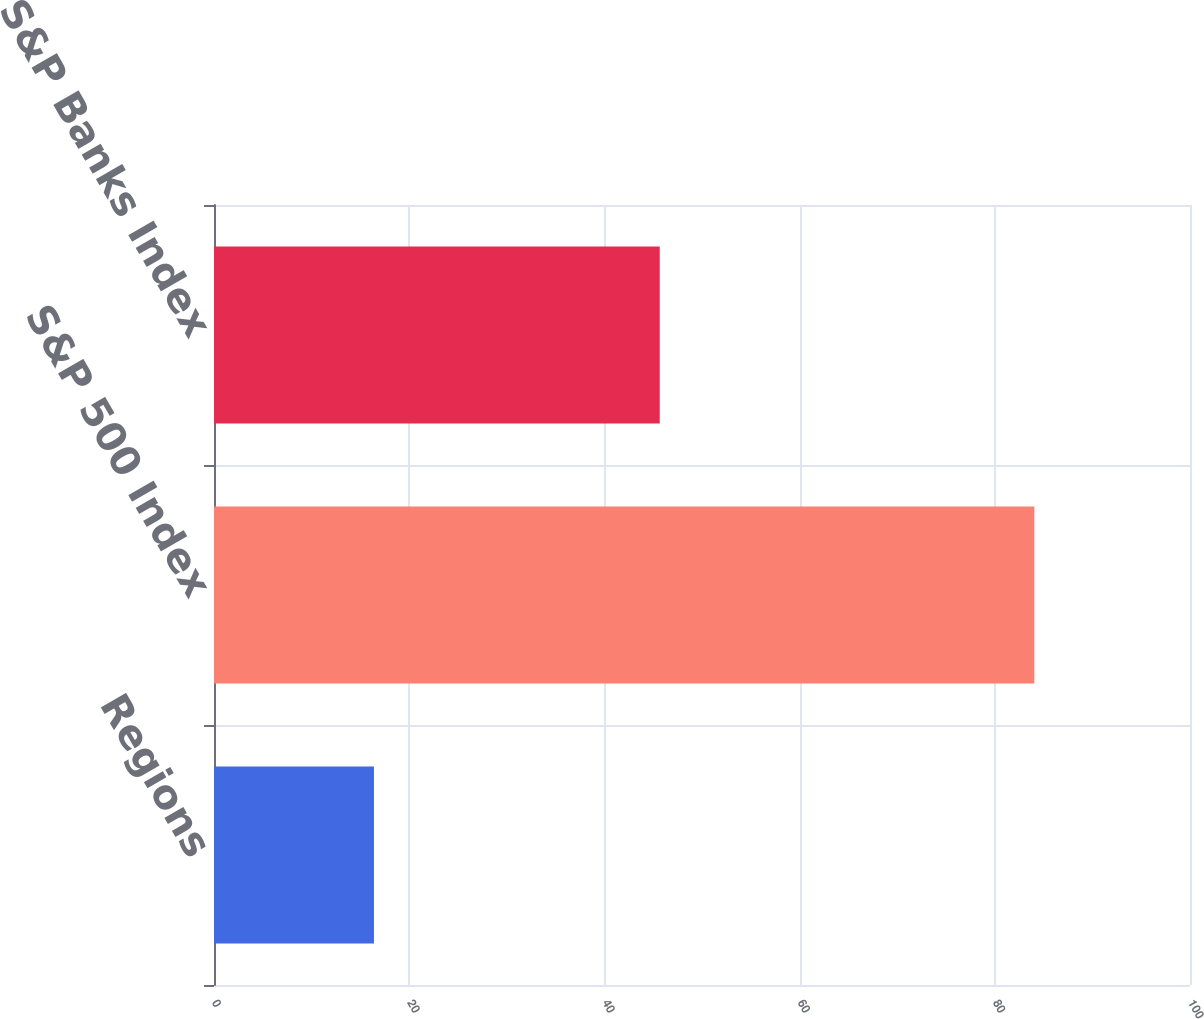Convert chart. <chart><loc_0><loc_0><loc_500><loc_500><bar_chart><fcel>Regions<fcel>S&P 500 Index<fcel>S&P Banks Index<nl><fcel>16.39<fcel>84.05<fcel>45.67<nl></chart> 